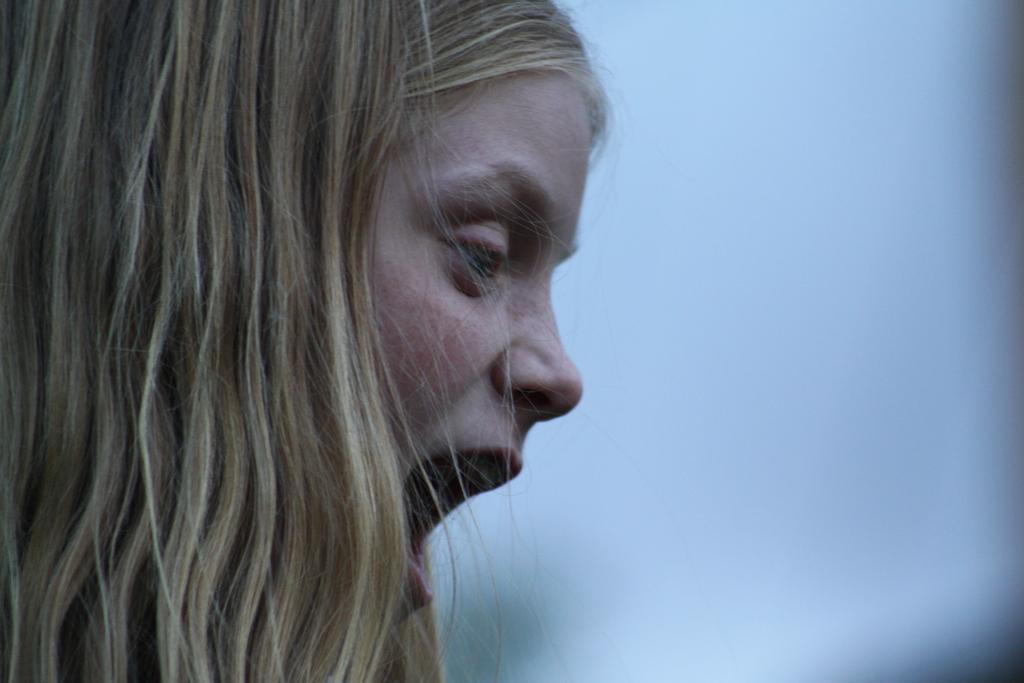Can you describe this image briefly? In this image in the foreground there is one woman who is opened her mouth. 